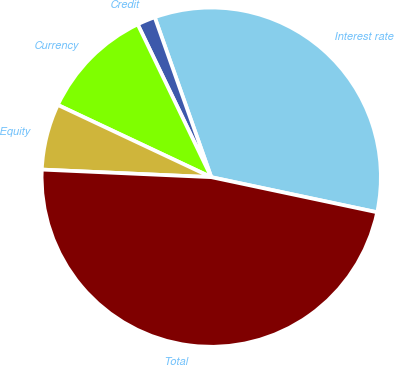<chart> <loc_0><loc_0><loc_500><loc_500><pie_chart><fcel>Interest rate<fcel>Credit<fcel>Currency<fcel>Equity<fcel>Total<nl><fcel>33.73%<fcel>1.73%<fcel>10.86%<fcel>6.29%<fcel>47.39%<nl></chart> 